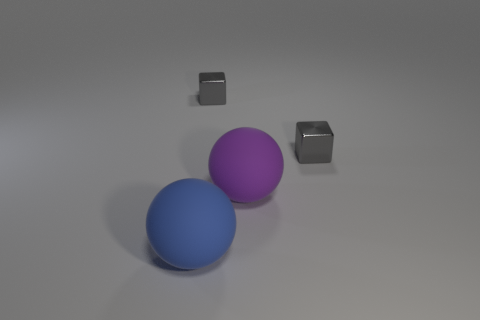What lighting effects are used in this image to highlight the objects? The image features soft, diffused lighting, likely from an overhead source, creating gentle shadows that enhance the dimensionality of the two spheres and two cubes. There's no harsh direct light, which contributes to the matte quality of the surfaces and allows the colors to remain vibrant. 